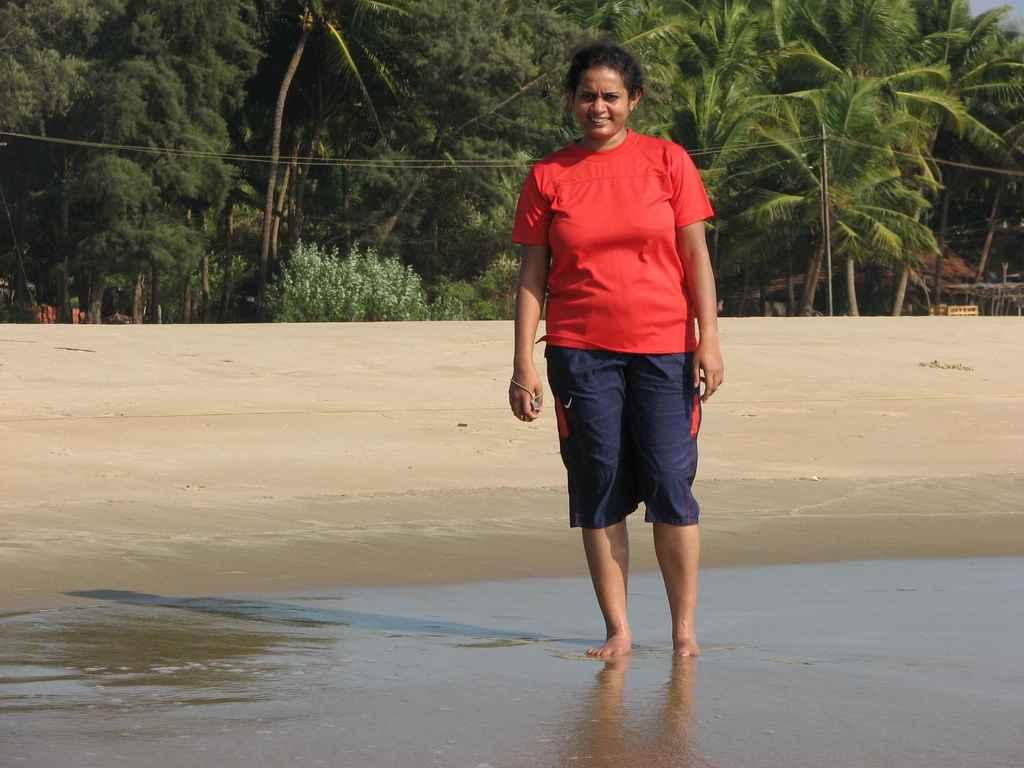Who is the main subject in the image? There is a woman in the image. What is the woman doing in the image? The woman is standing on land and holding some water. What is the woman wearing in the image? The woman is wearing a red shirt. What can be seen behind the woman in the image? There are plants and trees behind the woman. What type of protest is the woman participating in the image? There is no protest present in the image; it only shows a woman standing on land and holding water. Who is the woman's partner in the image? There is no partner present in the image; the woman is the only person shown. 